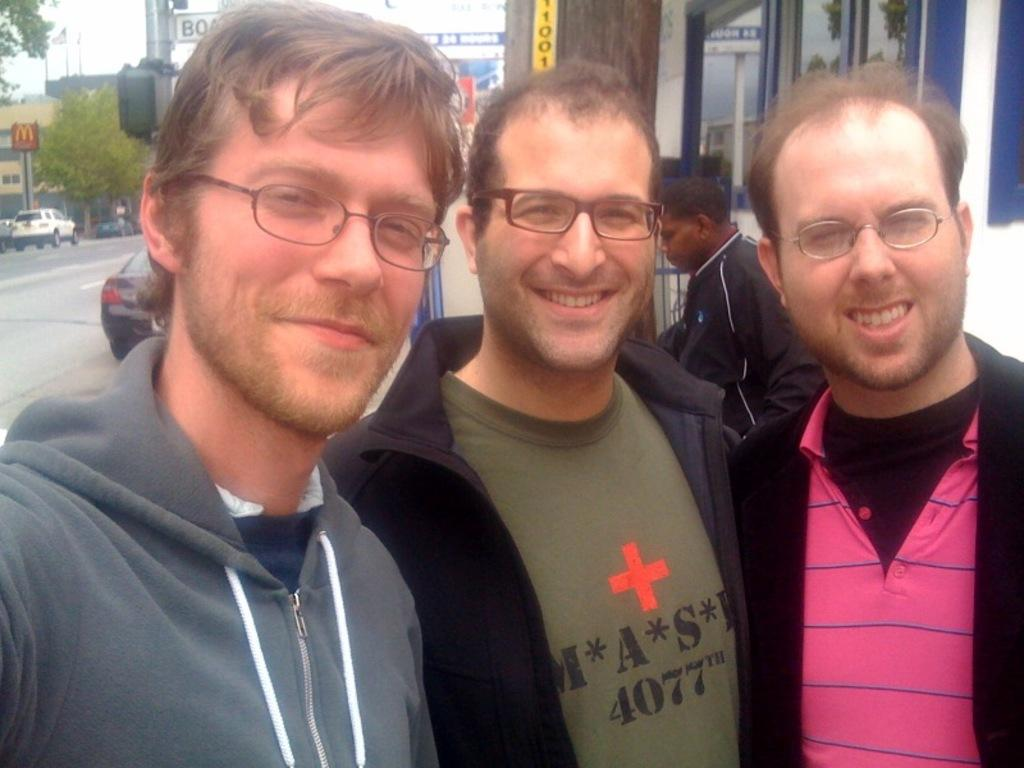How many persons are in the image? There are three persons standing in the middle of the image. What is the facial expression of the persons in the image? The persons are smiling. What can be seen in the background of the image? There are vehicles, buildings, trees, and poles in the background of the image. Are there any other people visible in the image? Yes, there is a person standing in the background of the image. What type of hand is visible in the image? There is no hand visible in the image; it only features three persons standing and a person in the background. What is the chance of winning a prize in the image? There is no indication of a prize or any game of chance in the image. 